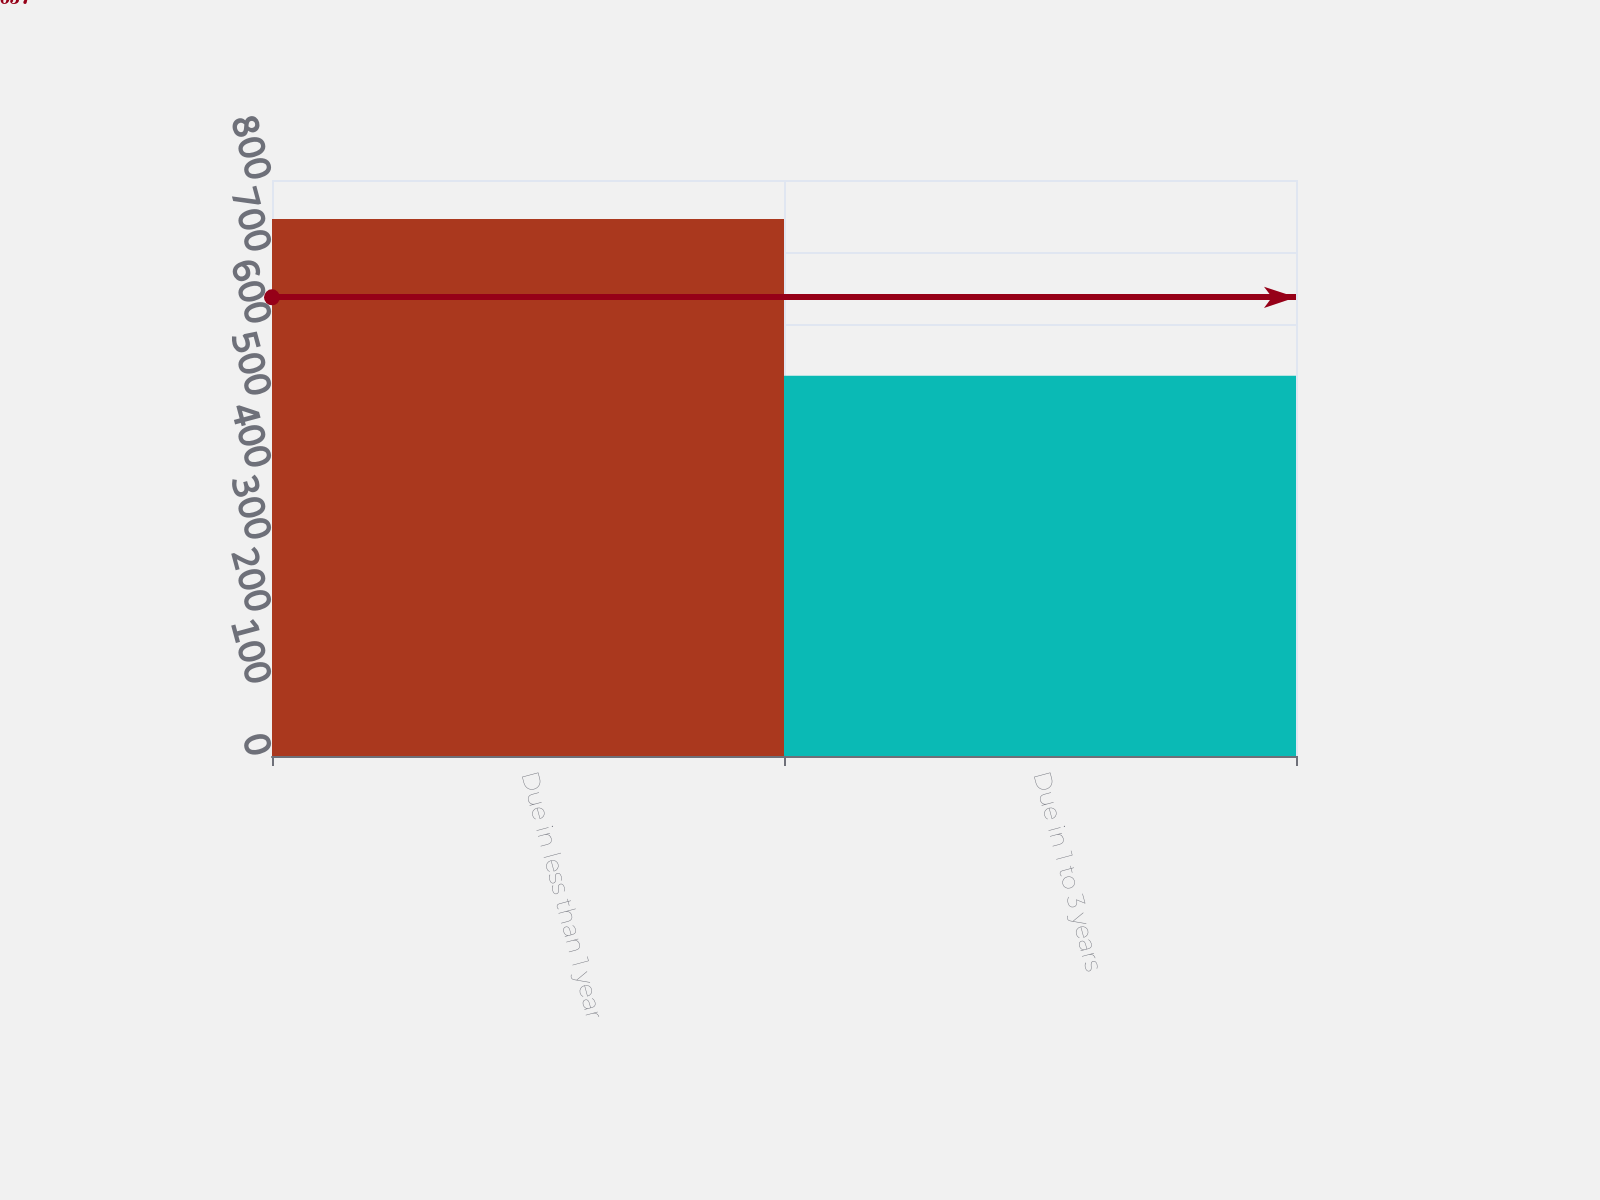Convert chart to OTSL. <chart><loc_0><loc_0><loc_500><loc_500><bar_chart><fcel>Due in less than 1 year<fcel>Due in 1 to 3 years<nl><fcel>746<fcel>528<nl></chart> 